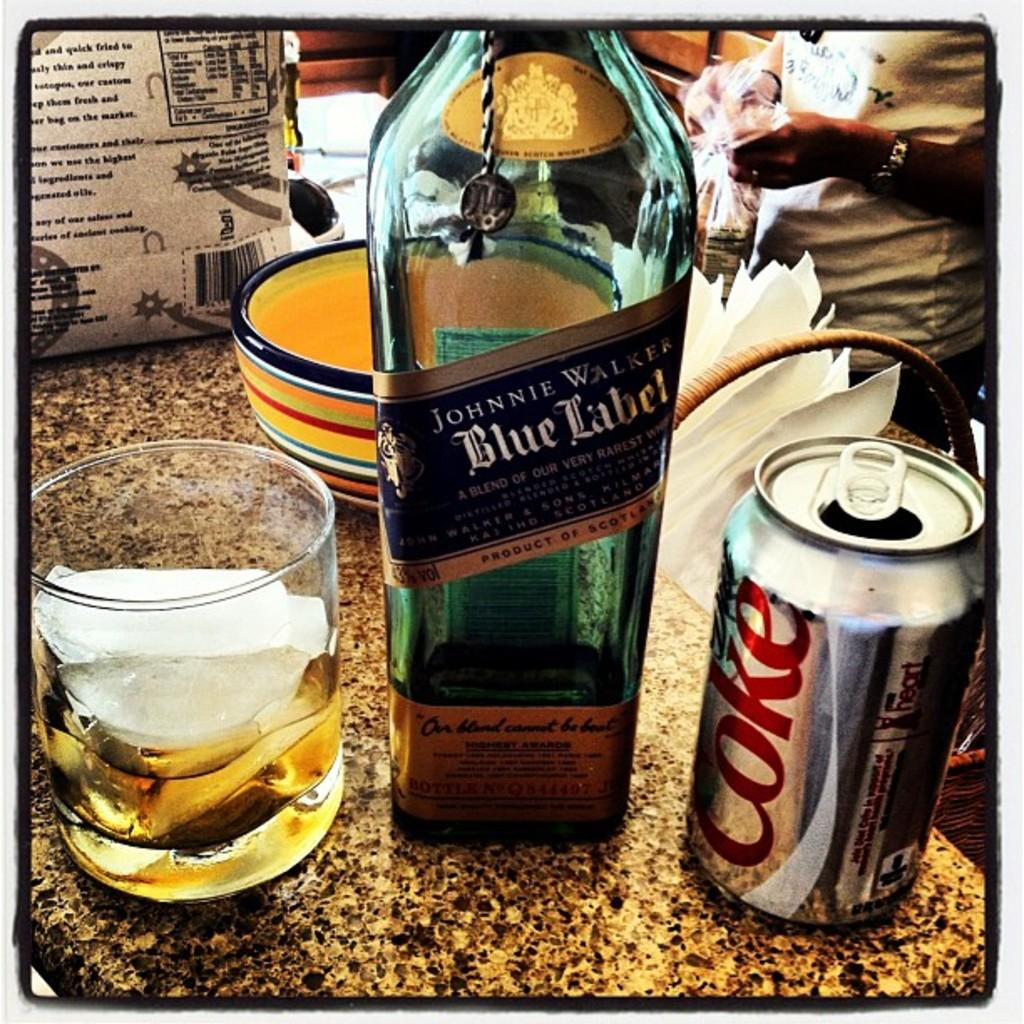<image>
Share a concise interpretation of the image provided. A can of Diet Coke sits next to a bottle of Johnnie Walker Blue Label. 